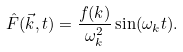Convert formula to latex. <formula><loc_0><loc_0><loc_500><loc_500>\hat { F } ( \vec { k } , t ) = \frac { f ( k ) } { \omega _ { k } ^ { 2 } } \sin ( \omega _ { k } t ) .</formula> 